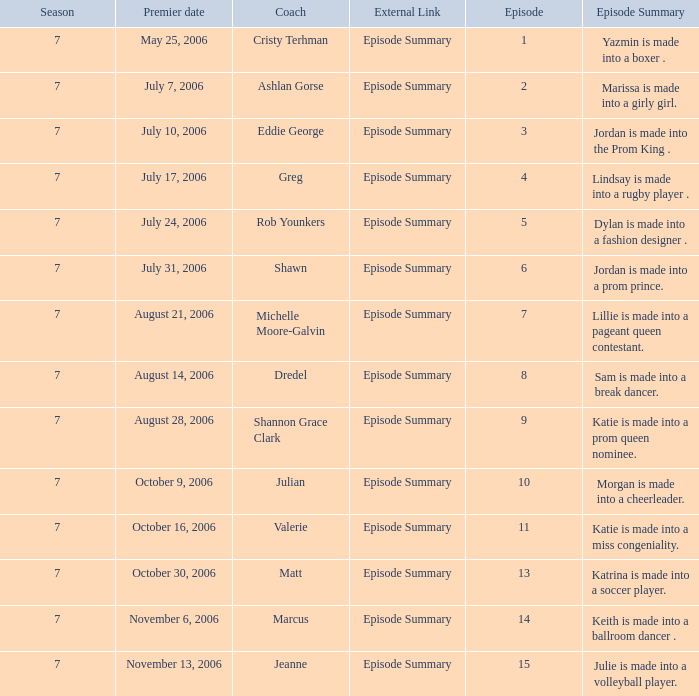How many episodes have a premier date of july 24, 2006 1.0. 